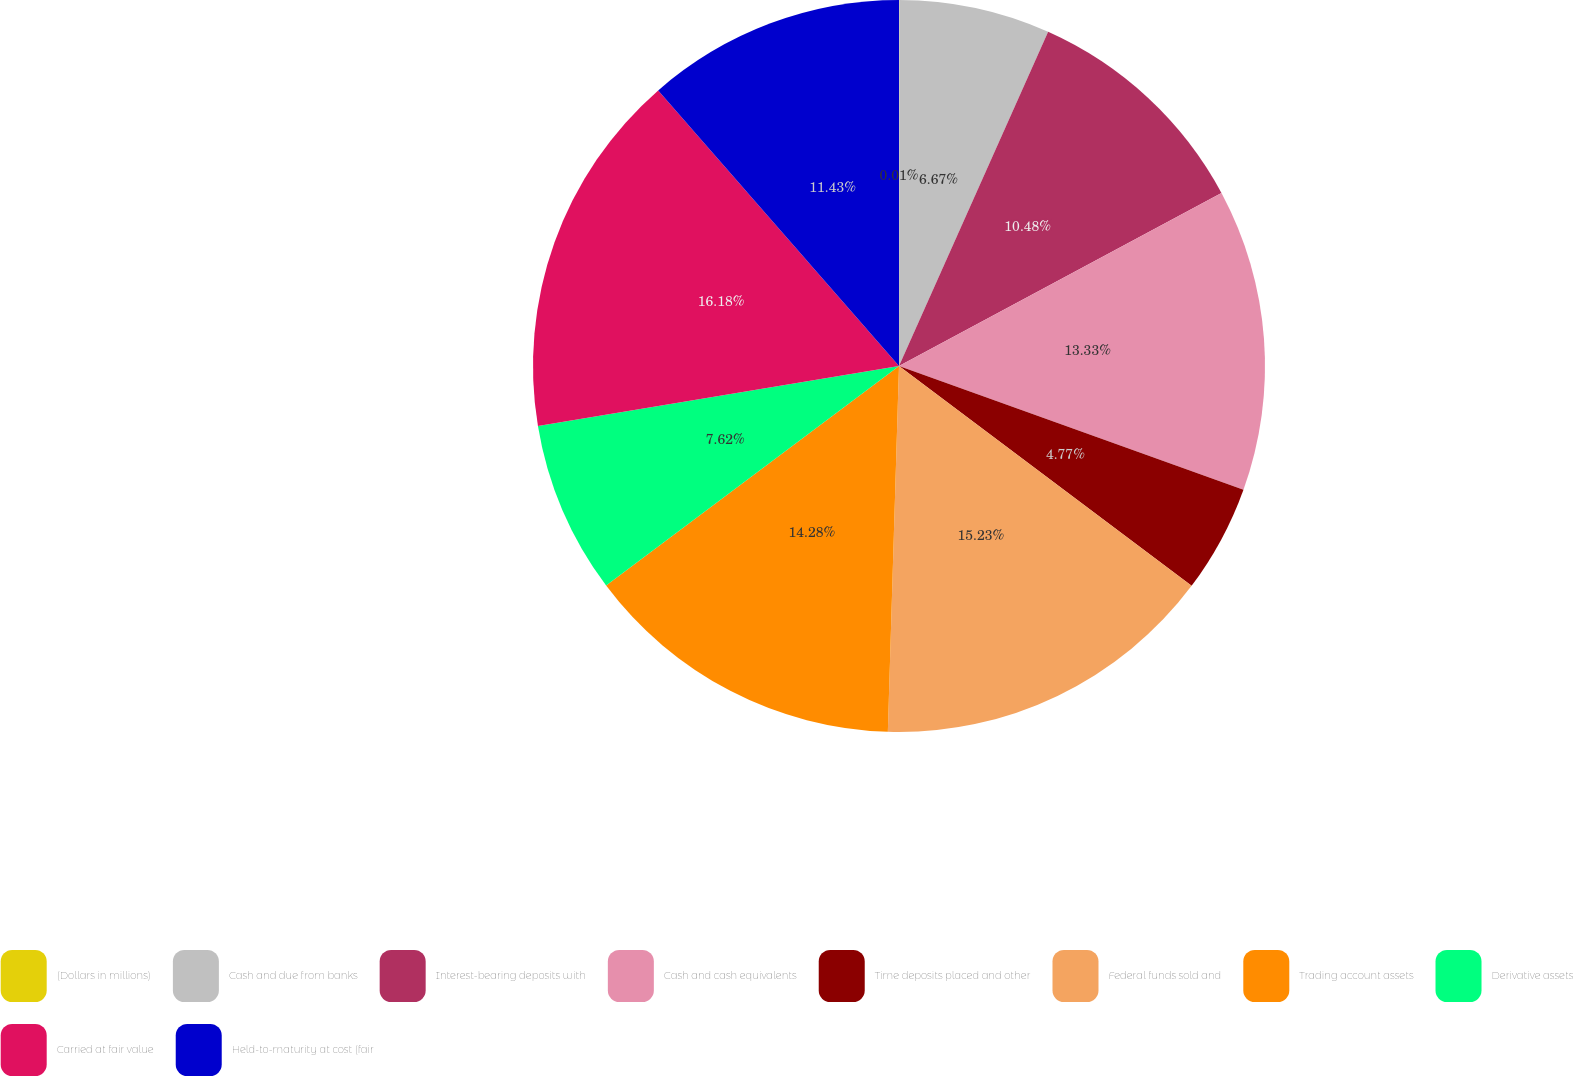Convert chart to OTSL. <chart><loc_0><loc_0><loc_500><loc_500><pie_chart><fcel>(Dollars in millions)<fcel>Cash and due from banks<fcel>Interest-bearing deposits with<fcel>Cash and cash equivalents<fcel>Time deposits placed and other<fcel>Federal funds sold and<fcel>Trading account assets<fcel>Derivative assets<fcel>Carried at fair value<fcel>Held-to-maturity at cost (fair<nl><fcel>0.01%<fcel>6.67%<fcel>10.48%<fcel>13.33%<fcel>4.77%<fcel>15.23%<fcel>14.28%<fcel>7.62%<fcel>16.19%<fcel>11.43%<nl></chart> 